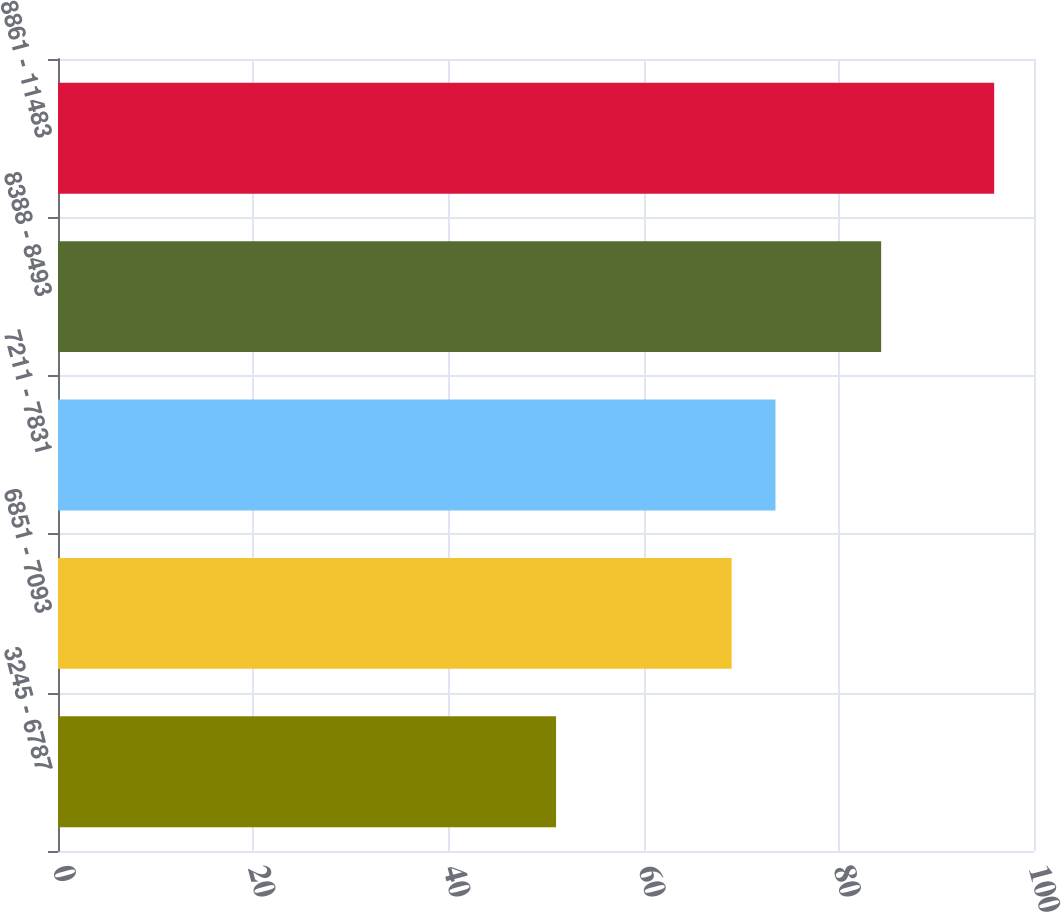<chart> <loc_0><loc_0><loc_500><loc_500><bar_chart><fcel>3245 - 6787<fcel>6851 - 7093<fcel>7211 - 7831<fcel>8388 - 8493<fcel>8861 - 11483<nl><fcel>51.03<fcel>69.02<fcel>73.51<fcel>84.34<fcel>95.92<nl></chart> 